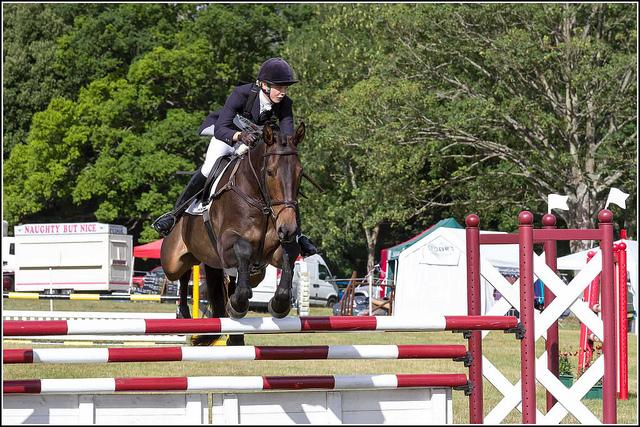What is this sport called?

Choices:
A) jumping
B) hurling
C) vaulting
D) sailing jumping 